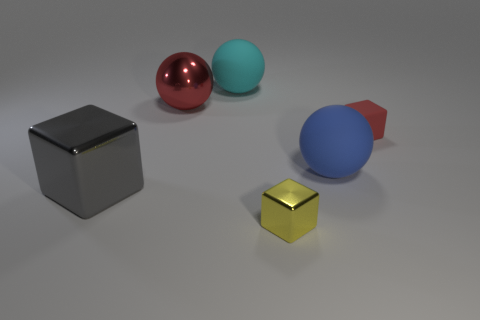There is a thing that is the same color as the large metallic ball; what material is it?
Offer a very short reply. Rubber. What number of other objects are the same color as the large metallic sphere?
Provide a succinct answer. 1. Does the big gray thing that is left of the red shiny ball have the same material as the small yellow object?
Offer a very short reply. Yes. There is a big object that is in front of the blue rubber object; what material is it?
Provide a succinct answer. Metal. There is a shiny cube in front of the big object that is left of the large red thing; how big is it?
Offer a very short reply. Small. Is there a large thing made of the same material as the big red sphere?
Provide a short and direct response. Yes. What shape is the tiny red object that is right of the red object that is left of the small thing left of the big blue thing?
Provide a short and direct response. Cube. Is the color of the big sphere on the left side of the cyan ball the same as the block to the right of the yellow thing?
Ensure brevity in your answer.  Yes. Are there any large objects behind the tiny red rubber object?
Give a very brief answer. Yes. How many large yellow things have the same shape as the red rubber thing?
Your answer should be very brief. 0. 